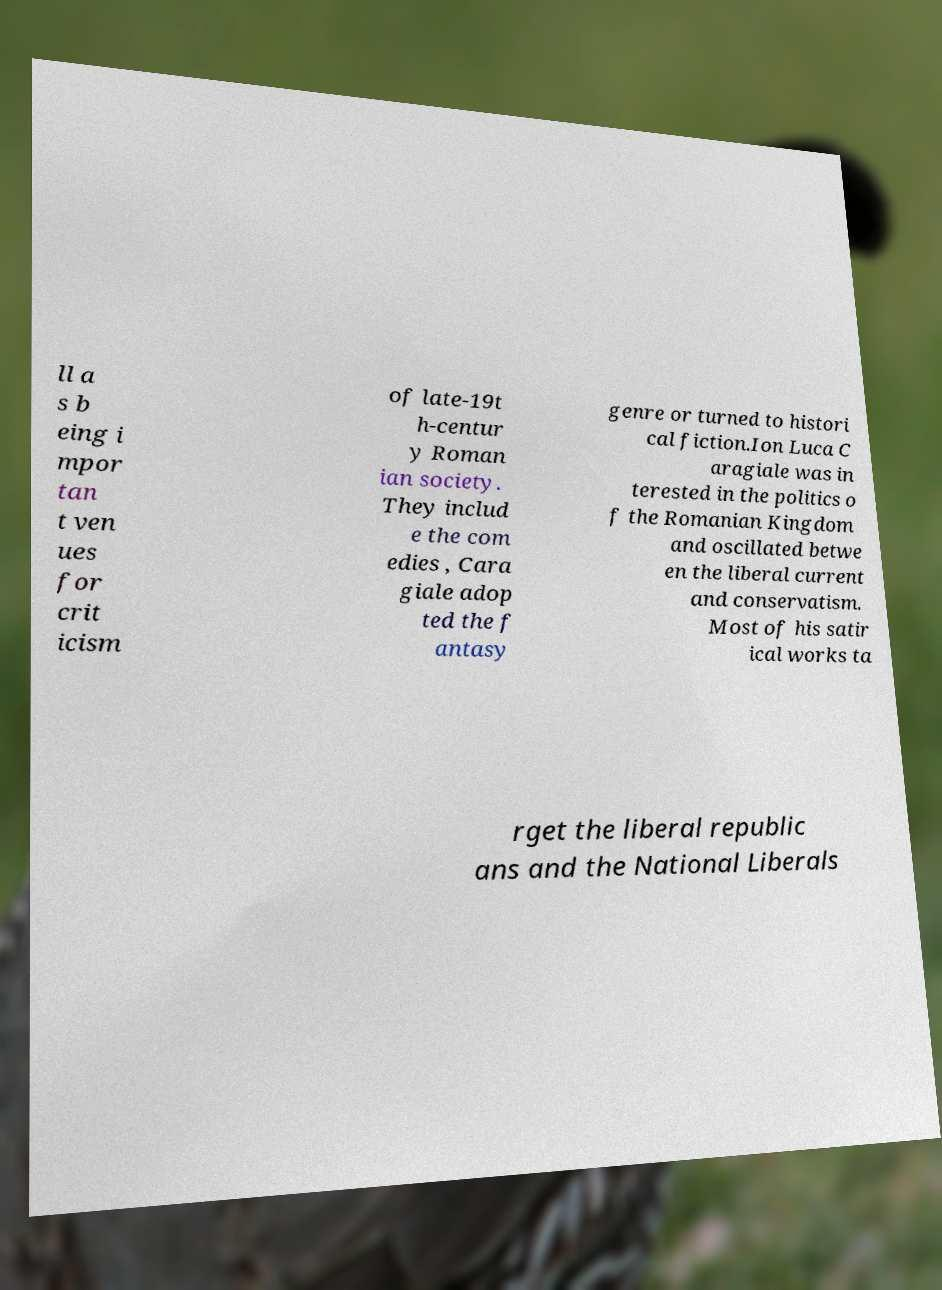I need the written content from this picture converted into text. Can you do that? ll a s b eing i mpor tan t ven ues for crit icism of late-19t h-centur y Roman ian society. They includ e the com edies , Cara giale adop ted the f antasy genre or turned to histori cal fiction.Ion Luca C aragiale was in terested in the politics o f the Romanian Kingdom and oscillated betwe en the liberal current and conservatism. Most of his satir ical works ta rget the liberal republic ans and the National Liberals 